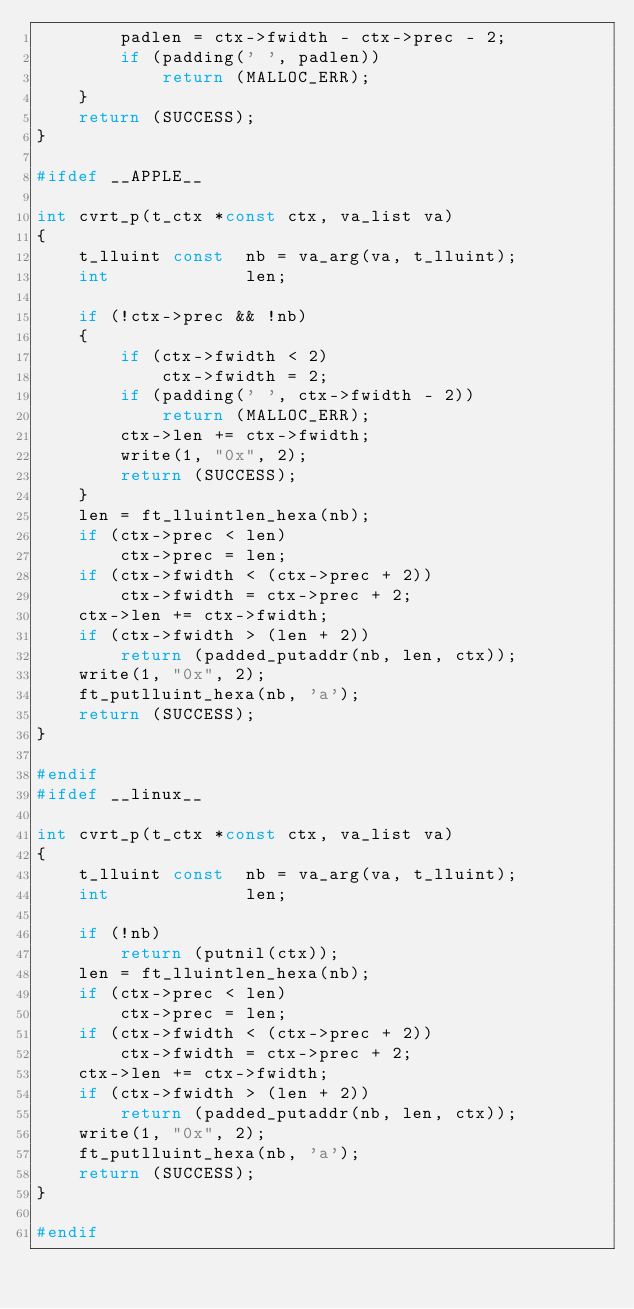Convert code to text. <code><loc_0><loc_0><loc_500><loc_500><_C_>		padlen = ctx->fwidth - ctx->prec - 2;
		if (padding(' ', padlen))
			return (MALLOC_ERR);
	}
	return (SUCCESS);
}

#ifdef __APPLE__

int	cvrt_p(t_ctx *const ctx, va_list va)
{
	t_lluint const	nb = va_arg(va, t_lluint);
	int				len;

	if (!ctx->prec && !nb)
	{
		if (ctx->fwidth < 2)
			ctx->fwidth = 2;
		if (padding(' ', ctx->fwidth - 2))
			return (MALLOC_ERR);
		ctx->len += ctx->fwidth;
		write(1, "0x", 2);
		return (SUCCESS);
	}
	len = ft_lluintlen_hexa(nb);
	if (ctx->prec < len)
		ctx->prec = len;
	if (ctx->fwidth < (ctx->prec + 2))
		ctx->fwidth = ctx->prec + 2;
	ctx->len += ctx->fwidth;
	if (ctx->fwidth > (len + 2))
		return (padded_putaddr(nb, len, ctx));
	write(1, "0x", 2);
	ft_putlluint_hexa(nb, 'a');
	return (SUCCESS);
}

#endif
#ifdef __linux__

int	cvrt_p(t_ctx *const ctx, va_list va)
{
	t_lluint const	nb = va_arg(va, t_lluint);
	int				len;

	if (!nb)
		return (putnil(ctx));
	len = ft_lluintlen_hexa(nb);
	if (ctx->prec < len)
		ctx->prec = len;
	if (ctx->fwidth < (ctx->prec + 2))
		ctx->fwidth = ctx->prec + 2;
	ctx->len += ctx->fwidth;
	if (ctx->fwidth > (len + 2))
		return (padded_putaddr(nb, len, ctx));
	write(1, "0x", 2);
	ft_putlluint_hexa(nb, 'a');
	return (SUCCESS);
}

#endif
</code> 